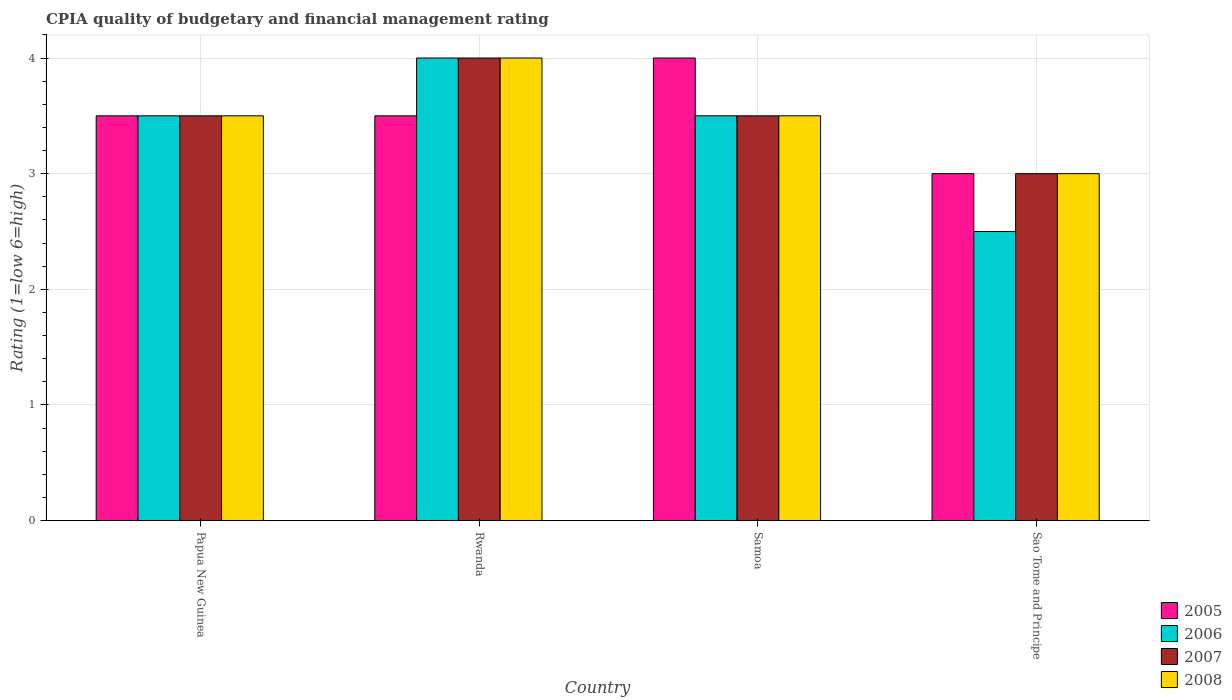Are the number of bars on each tick of the X-axis equal?
Your response must be concise. Yes. How many bars are there on the 3rd tick from the left?
Ensure brevity in your answer.  4. How many bars are there on the 4th tick from the right?
Ensure brevity in your answer.  4. What is the label of the 3rd group of bars from the left?
Offer a terse response. Samoa. In how many cases, is the number of bars for a given country not equal to the number of legend labels?
Provide a short and direct response. 0. In which country was the CPIA rating in 2006 maximum?
Provide a succinct answer. Rwanda. In which country was the CPIA rating in 2007 minimum?
Your answer should be very brief. Sao Tome and Principe. What is the difference between the CPIA rating in 2006 in Papua New Guinea and that in Sao Tome and Principe?
Your answer should be very brief. 1. What is the difference between the CPIA rating in 2008 in Rwanda and the CPIA rating in 2005 in Sao Tome and Principe?
Give a very brief answer. 1. What is the average CPIA rating in 2006 per country?
Offer a terse response. 3.38. What is the difference between the CPIA rating of/in 2006 and CPIA rating of/in 2007 in Samoa?
Give a very brief answer. 0. In how many countries, is the CPIA rating in 2005 greater than 0.2?
Your answer should be compact. 4. What is the ratio of the CPIA rating in 2008 in Rwanda to that in Sao Tome and Principe?
Your answer should be very brief. 1.33. Is the CPIA rating in 2005 in Papua New Guinea less than that in Samoa?
Make the answer very short. Yes. What is the difference between the highest and the second highest CPIA rating in 2006?
Keep it short and to the point. -0.5. What is the difference between the highest and the lowest CPIA rating in 2008?
Offer a terse response. 1. Is the sum of the CPIA rating in 2005 in Papua New Guinea and Sao Tome and Principe greater than the maximum CPIA rating in 2006 across all countries?
Give a very brief answer. Yes. What does the 3rd bar from the left in Papua New Guinea represents?
Provide a succinct answer. 2007. What does the 2nd bar from the right in Samoa represents?
Keep it short and to the point. 2007. Is it the case that in every country, the sum of the CPIA rating in 2008 and CPIA rating in 2005 is greater than the CPIA rating in 2007?
Provide a short and direct response. Yes. How many bars are there?
Offer a terse response. 16. Are all the bars in the graph horizontal?
Your answer should be very brief. No. How many countries are there in the graph?
Give a very brief answer. 4. Are the values on the major ticks of Y-axis written in scientific E-notation?
Keep it short and to the point. No. Does the graph contain any zero values?
Your answer should be very brief. No. Does the graph contain grids?
Your answer should be compact. Yes. Where does the legend appear in the graph?
Your answer should be very brief. Bottom right. How many legend labels are there?
Provide a short and direct response. 4. What is the title of the graph?
Ensure brevity in your answer.  CPIA quality of budgetary and financial management rating. Does "1989" appear as one of the legend labels in the graph?
Keep it short and to the point. No. What is the label or title of the Y-axis?
Ensure brevity in your answer.  Rating (1=low 6=high). What is the Rating (1=low 6=high) of 2006 in Papua New Guinea?
Keep it short and to the point. 3.5. What is the Rating (1=low 6=high) in 2007 in Papua New Guinea?
Make the answer very short. 3.5. What is the Rating (1=low 6=high) in 2005 in Rwanda?
Your answer should be very brief. 3.5. What is the Rating (1=low 6=high) in 2006 in Rwanda?
Your answer should be very brief. 4. What is the Rating (1=low 6=high) in 2007 in Rwanda?
Make the answer very short. 4. What is the Rating (1=low 6=high) in 2008 in Rwanda?
Ensure brevity in your answer.  4. What is the Rating (1=low 6=high) in 2006 in Samoa?
Keep it short and to the point. 3.5. What is the Rating (1=low 6=high) in 2007 in Samoa?
Provide a short and direct response. 3.5. What is the Rating (1=low 6=high) of 2008 in Sao Tome and Principe?
Make the answer very short. 3. Across all countries, what is the maximum Rating (1=low 6=high) of 2007?
Ensure brevity in your answer.  4. Across all countries, what is the maximum Rating (1=low 6=high) of 2008?
Your response must be concise. 4. Across all countries, what is the minimum Rating (1=low 6=high) of 2005?
Give a very brief answer. 3. What is the total Rating (1=low 6=high) in 2007 in the graph?
Provide a succinct answer. 14. What is the difference between the Rating (1=low 6=high) in 2005 in Papua New Guinea and that in Rwanda?
Provide a succinct answer. 0. What is the difference between the Rating (1=low 6=high) in 2007 in Papua New Guinea and that in Rwanda?
Give a very brief answer. -0.5. What is the difference between the Rating (1=low 6=high) of 2005 in Papua New Guinea and that in Samoa?
Offer a very short reply. -0.5. What is the difference between the Rating (1=low 6=high) of 2007 in Papua New Guinea and that in Samoa?
Ensure brevity in your answer.  0. What is the difference between the Rating (1=low 6=high) in 2006 in Papua New Guinea and that in Sao Tome and Principe?
Provide a succinct answer. 1. What is the difference between the Rating (1=low 6=high) in 2007 in Papua New Guinea and that in Sao Tome and Principe?
Ensure brevity in your answer.  0.5. What is the difference between the Rating (1=low 6=high) in 2005 in Rwanda and that in Samoa?
Provide a succinct answer. -0.5. What is the difference between the Rating (1=low 6=high) of 2006 in Rwanda and that in Samoa?
Your response must be concise. 0.5. What is the difference between the Rating (1=low 6=high) in 2006 in Rwanda and that in Sao Tome and Principe?
Make the answer very short. 1.5. What is the difference between the Rating (1=low 6=high) of 2007 in Rwanda and that in Sao Tome and Principe?
Give a very brief answer. 1. What is the difference between the Rating (1=low 6=high) of 2005 in Samoa and that in Sao Tome and Principe?
Your answer should be compact. 1. What is the difference between the Rating (1=low 6=high) of 2006 in Samoa and that in Sao Tome and Principe?
Make the answer very short. 1. What is the difference between the Rating (1=low 6=high) in 2007 in Samoa and that in Sao Tome and Principe?
Provide a succinct answer. 0.5. What is the difference between the Rating (1=low 6=high) in 2008 in Samoa and that in Sao Tome and Principe?
Provide a succinct answer. 0.5. What is the difference between the Rating (1=low 6=high) in 2005 in Papua New Guinea and the Rating (1=low 6=high) in 2006 in Rwanda?
Provide a succinct answer. -0.5. What is the difference between the Rating (1=low 6=high) in 2005 in Papua New Guinea and the Rating (1=low 6=high) in 2007 in Rwanda?
Keep it short and to the point. -0.5. What is the difference between the Rating (1=low 6=high) of 2005 in Papua New Guinea and the Rating (1=low 6=high) of 2008 in Rwanda?
Keep it short and to the point. -0.5. What is the difference between the Rating (1=low 6=high) in 2005 in Papua New Guinea and the Rating (1=low 6=high) in 2007 in Samoa?
Make the answer very short. 0. What is the difference between the Rating (1=low 6=high) of 2006 in Papua New Guinea and the Rating (1=low 6=high) of 2008 in Samoa?
Ensure brevity in your answer.  0. What is the difference between the Rating (1=low 6=high) of 2005 in Papua New Guinea and the Rating (1=low 6=high) of 2006 in Sao Tome and Principe?
Offer a very short reply. 1. What is the difference between the Rating (1=low 6=high) in 2005 in Papua New Guinea and the Rating (1=low 6=high) in 2008 in Sao Tome and Principe?
Offer a very short reply. 0.5. What is the difference between the Rating (1=low 6=high) in 2006 in Papua New Guinea and the Rating (1=low 6=high) in 2007 in Sao Tome and Principe?
Give a very brief answer. 0.5. What is the difference between the Rating (1=low 6=high) in 2005 in Rwanda and the Rating (1=low 6=high) in 2006 in Samoa?
Make the answer very short. 0. What is the difference between the Rating (1=low 6=high) of 2005 in Rwanda and the Rating (1=low 6=high) of 2007 in Samoa?
Give a very brief answer. 0. What is the difference between the Rating (1=low 6=high) in 2005 in Rwanda and the Rating (1=low 6=high) in 2008 in Samoa?
Keep it short and to the point. 0. What is the difference between the Rating (1=low 6=high) in 2006 in Rwanda and the Rating (1=low 6=high) in 2007 in Samoa?
Provide a succinct answer. 0.5. What is the difference between the Rating (1=low 6=high) in 2006 in Rwanda and the Rating (1=low 6=high) in 2008 in Samoa?
Your answer should be very brief. 0.5. What is the difference between the Rating (1=low 6=high) in 2007 in Rwanda and the Rating (1=low 6=high) in 2008 in Samoa?
Provide a short and direct response. 0.5. What is the difference between the Rating (1=low 6=high) in 2005 in Rwanda and the Rating (1=low 6=high) in 2008 in Sao Tome and Principe?
Keep it short and to the point. 0.5. What is the difference between the Rating (1=low 6=high) in 2006 in Rwanda and the Rating (1=low 6=high) in 2008 in Sao Tome and Principe?
Give a very brief answer. 1. What is the difference between the Rating (1=low 6=high) in 2007 in Rwanda and the Rating (1=low 6=high) in 2008 in Sao Tome and Principe?
Offer a very short reply. 1. What is the difference between the Rating (1=low 6=high) in 2005 in Samoa and the Rating (1=low 6=high) in 2006 in Sao Tome and Principe?
Provide a succinct answer. 1.5. What is the difference between the Rating (1=low 6=high) in 2005 in Samoa and the Rating (1=low 6=high) in 2007 in Sao Tome and Principe?
Make the answer very short. 1. What is the difference between the Rating (1=low 6=high) of 2005 in Samoa and the Rating (1=low 6=high) of 2008 in Sao Tome and Principe?
Keep it short and to the point. 1. What is the difference between the Rating (1=low 6=high) in 2006 in Samoa and the Rating (1=low 6=high) in 2007 in Sao Tome and Principe?
Offer a very short reply. 0.5. What is the average Rating (1=low 6=high) in 2005 per country?
Offer a terse response. 3.5. What is the average Rating (1=low 6=high) of 2006 per country?
Keep it short and to the point. 3.38. What is the average Rating (1=low 6=high) of 2007 per country?
Provide a succinct answer. 3.5. What is the average Rating (1=low 6=high) of 2008 per country?
Make the answer very short. 3.5. What is the difference between the Rating (1=low 6=high) of 2005 and Rating (1=low 6=high) of 2006 in Papua New Guinea?
Your answer should be compact. 0. What is the difference between the Rating (1=low 6=high) of 2005 and Rating (1=low 6=high) of 2007 in Papua New Guinea?
Ensure brevity in your answer.  0. What is the difference between the Rating (1=low 6=high) of 2006 and Rating (1=low 6=high) of 2007 in Papua New Guinea?
Provide a succinct answer. 0. What is the difference between the Rating (1=low 6=high) in 2006 and Rating (1=low 6=high) in 2008 in Papua New Guinea?
Make the answer very short. 0. What is the difference between the Rating (1=low 6=high) of 2007 and Rating (1=low 6=high) of 2008 in Papua New Guinea?
Offer a terse response. 0. What is the difference between the Rating (1=low 6=high) of 2005 and Rating (1=low 6=high) of 2007 in Rwanda?
Ensure brevity in your answer.  -0.5. What is the difference between the Rating (1=low 6=high) of 2005 and Rating (1=low 6=high) of 2008 in Rwanda?
Keep it short and to the point. -0.5. What is the difference between the Rating (1=low 6=high) in 2006 and Rating (1=low 6=high) in 2007 in Rwanda?
Offer a terse response. 0. What is the difference between the Rating (1=low 6=high) of 2005 and Rating (1=low 6=high) of 2007 in Samoa?
Give a very brief answer. 0.5. What is the difference between the Rating (1=low 6=high) in 2005 and Rating (1=low 6=high) in 2008 in Samoa?
Your answer should be very brief. 0.5. What is the difference between the Rating (1=low 6=high) in 2007 and Rating (1=low 6=high) in 2008 in Samoa?
Your response must be concise. 0. What is the difference between the Rating (1=low 6=high) in 2006 and Rating (1=low 6=high) in 2008 in Sao Tome and Principe?
Make the answer very short. -0.5. What is the difference between the Rating (1=low 6=high) of 2007 and Rating (1=low 6=high) of 2008 in Sao Tome and Principe?
Provide a short and direct response. 0. What is the ratio of the Rating (1=low 6=high) in 2005 in Papua New Guinea to that in Rwanda?
Provide a succinct answer. 1. What is the ratio of the Rating (1=low 6=high) of 2005 in Papua New Guinea to that in Samoa?
Your answer should be very brief. 0.88. What is the ratio of the Rating (1=low 6=high) in 2007 in Papua New Guinea to that in Samoa?
Make the answer very short. 1. What is the ratio of the Rating (1=low 6=high) in 2008 in Papua New Guinea to that in Samoa?
Your response must be concise. 1. What is the ratio of the Rating (1=low 6=high) of 2005 in Papua New Guinea to that in Sao Tome and Principe?
Keep it short and to the point. 1.17. What is the ratio of the Rating (1=low 6=high) in 2007 in Papua New Guinea to that in Sao Tome and Principe?
Provide a succinct answer. 1.17. What is the ratio of the Rating (1=low 6=high) of 2008 in Papua New Guinea to that in Sao Tome and Principe?
Offer a terse response. 1.17. What is the ratio of the Rating (1=low 6=high) of 2005 in Rwanda to that in Samoa?
Provide a short and direct response. 0.88. What is the ratio of the Rating (1=low 6=high) of 2007 in Rwanda to that in Samoa?
Provide a short and direct response. 1.14. What is the ratio of the Rating (1=low 6=high) in 2008 in Rwanda to that in Samoa?
Your answer should be very brief. 1.14. What is the ratio of the Rating (1=low 6=high) of 2006 in Rwanda to that in Sao Tome and Principe?
Your answer should be compact. 1.6. What is the ratio of the Rating (1=low 6=high) of 2007 in Rwanda to that in Sao Tome and Principe?
Make the answer very short. 1.33. What is the ratio of the Rating (1=low 6=high) in 2008 in Rwanda to that in Sao Tome and Principe?
Your response must be concise. 1.33. What is the ratio of the Rating (1=low 6=high) in 2005 in Samoa to that in Sao Tome and Principe?
Give a very brief answer. 1.33. What is the difference between the highest and the second highest Rating (1=low 6=high) of 2005?
Your answer should be compact. 0.5. What is the difference between the highest and the second highest Rating (1=low 6=high) in 2007?
Provide a succinct answer. 0.5. What is the difference between the highest and the second highest Rating (1=low 6=high) in 2008?
Provide a succinct answer. 0.5. What is the difference between the highest and the lowest Rating (1=low 6=high) of 2005?
Make the answer very short. 1. What is the difference between the highest and the lowest Rating (1=low 6=high) in 2006?
Give a very brief answer. 1.5. What is the difference between the highest and the lowest Rating (1=low 6=high) in 2008?
Your answer should be very brief. 1. 